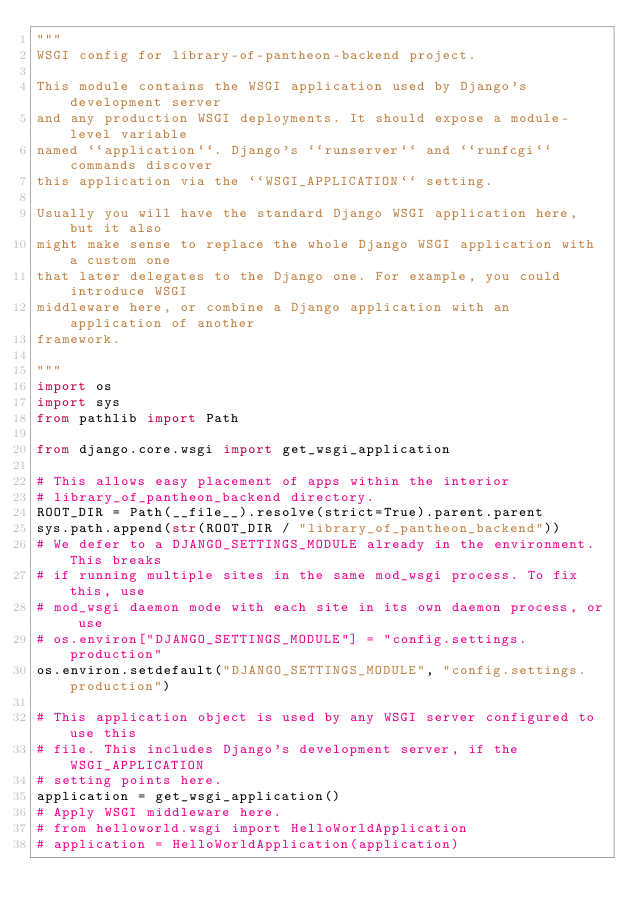Convert code to text. <code><loc_0><loc_0><loc_500><loc_500><_Python_>"""
WSGI config for library-of-pantheon-backend project.

This module contains the WSGI application used by Django's development server
and any production WSGI deployments. It should expose a module-level variable
named ``application``. Django's ``runserver`` and ``runfcgi`` commands discover
this application via the ``WSGI_APPLICATION`` setting.

Usually you will have the standard Django WSGI application here, but it also
might make sense to replace the whole Django WSGI application with a custom one
that later delegates to the Django one. For example, you could introduce WSGI
middleware here, or combine a Django application with an application of another
framework.

"""
import os
import sys
from pathlib import Path

from django.core.wsgi import get_wsgi_application

# This allows easy placement of apps within the interior
# library_of_pantheon_backend directory.
ROOT_DIR = Path(__file__).resolve(strict=True).parent.parent
sys.path.append(str(ROOT_DIR / "library_of_pantheon_backend"))
# We defer to a DJANGO_SETTINGS_MODULE already in the environment. This breaks
# if running multiple sites in the same mod_wsgi process. To fix this, use
# mod_wsgi daemon mode with each site in its own daemon process, or use
# os.environ["DJANGO_SETTINGS_MODULE"] = "config.settings.production"
os.environ.setdefault("DJANGO_SETTINGS_MODULE", "config.settings.production")

# This application object is used by any WSGI server configured to use this
# file. This includes Django's development server, if the WSGI_APPLICATION
# setting points here.
application = get_wsgi_application()
# Apply WSGI middleware here.
# from helloworld.wsgi import HelloWorldApplication
# application = HelloWorldApplication(application)
</code> 